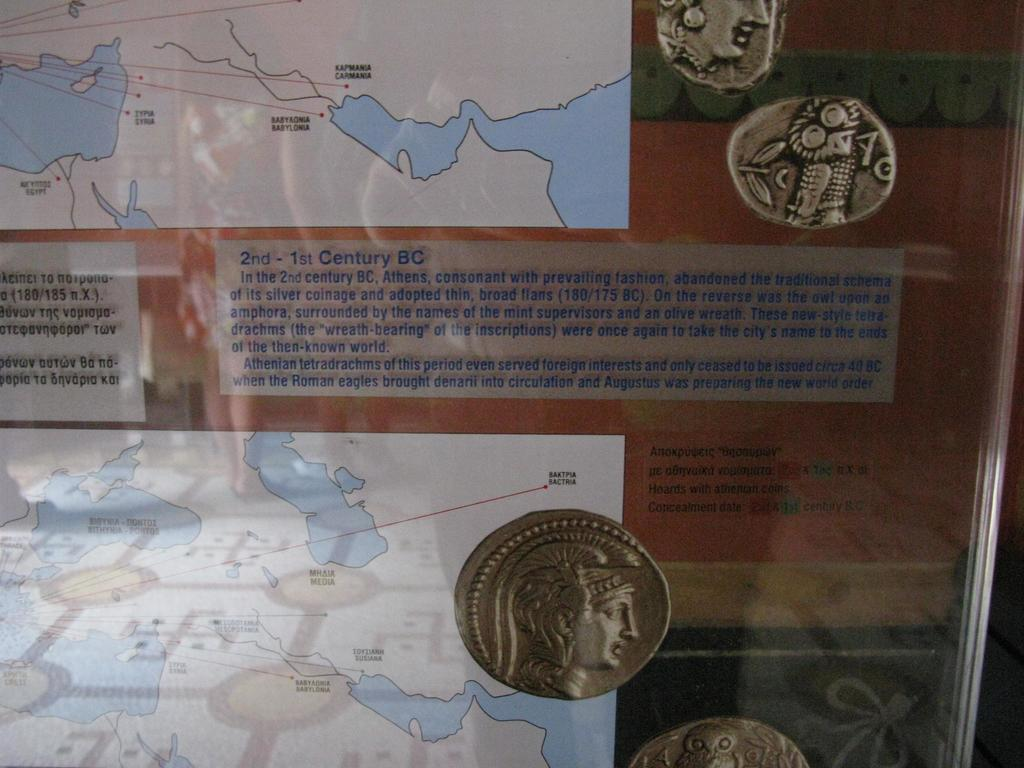<image>
Relay a brief, clear account of the picture shown. A map with a label underneath it with the title 2nd-1st Century BC. 